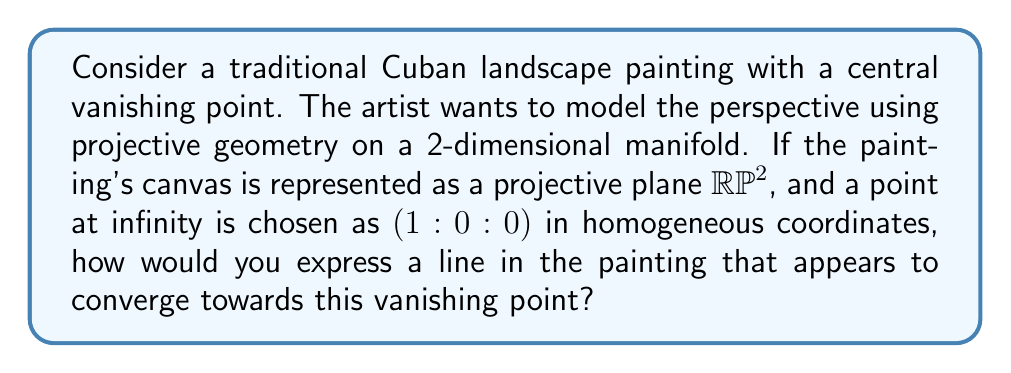Solve this math problem. To model the perspective in this Cuban landscape painting using projective geometry on a 2-dimensional manifold, we'll follow these steps:

1) First, recall that the projective plane $\mathbb{RP}^2$ is a 2-dimensional manifold that can be used to represent points at infinity.

2) In the projective plane, points are represented using homogeneous coordinates $(x:y:z)$, where not all coordinates are zero, and $(x:y:z) = (λx:λy:λz)$ for any non-zero scalar λ.

3) The point at infinity $(1:0:0)$ represents the vanishing point in our painting. This point lies on the line at infinity in $\mathbb{RP}^2$.

4) A general line in $\mathbb{RP}^2$ can be represented by the equation:

   $$ax + by + cz = 0$$

   where $(a:b:c)$ are the homogeneous coordinates of the line.

5) For a line to pass through the point at infinity $(1:0:0)$, it must satisfy:

   $$a(1) + b(0) + c(0) = 0$$

   This implies that $a = 0$.

6) Therefore, any line converging towards the vanishing point $(1:0:0)$ will have the form:

   $$by + cz = 0$$

7) We can normalize this by setting $b = 1$ (assuming $b ≠ 0$), giving us:

   $$y + kz = 0$$

   where $k = c/b$ is a real number that determines the specific line.

8) In the affine part of the projective plane (where $z ≠ 0$), we can divide by $z$ to get:

   $$\frac{y}{z} + k = 0$$

   or $y = -kz$, which is the equation of a straight line in the usual Cartesian coordinates.

This representation allows us to model any line in the painting that appears to converge towards the chosen vanishing point.
Answer: The line in the painting converging towards the vanishing point $(1:0:0)$ can be expressed in $\mathbb{RP}^2$ as:

$$y + kz = 0$$

where $k$ is a real number determining the specific line. 